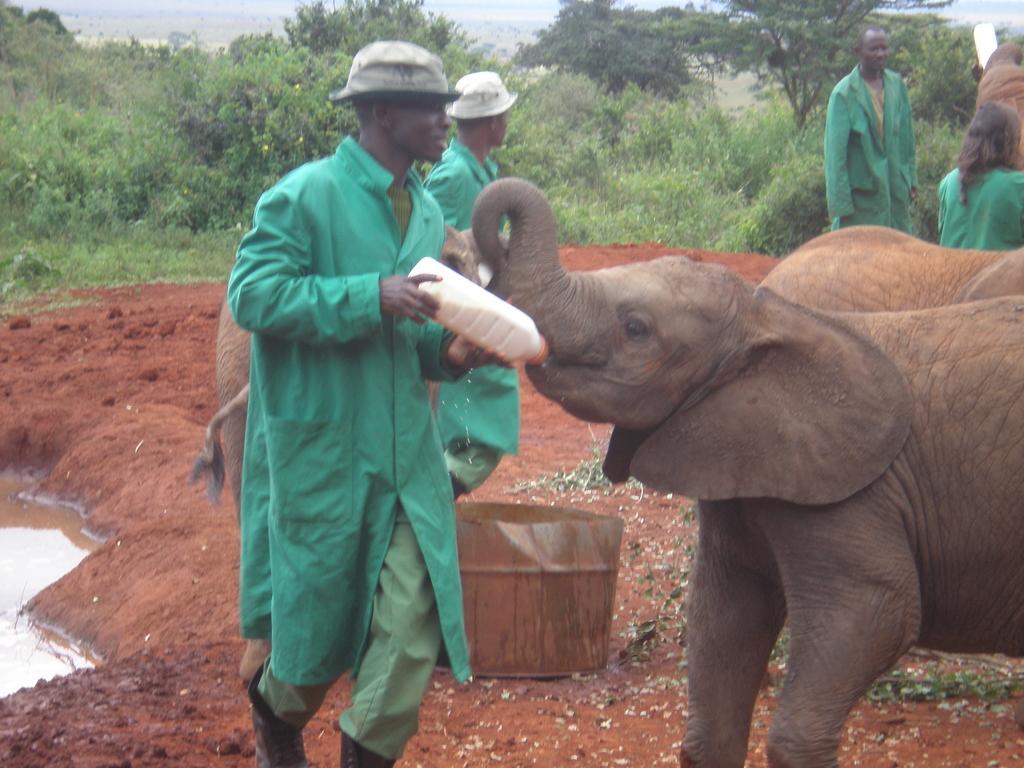In one or two sentences, can you explain what this image depicts? In the center of the image there is a person wearing a green color apron and holding a milk bottle in his hand. There is a baby elephant. In the background of the image there are trees. There are people. At the bottom of the image there is mud. To the left side of the image there is water. 